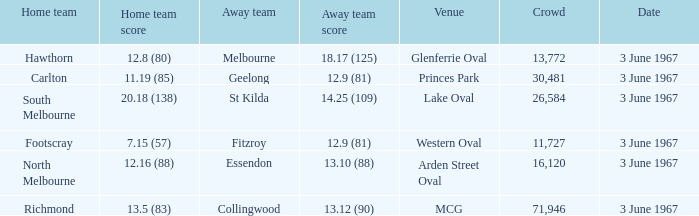Where was the match held when geelong performed as the away team? Princes Park. 